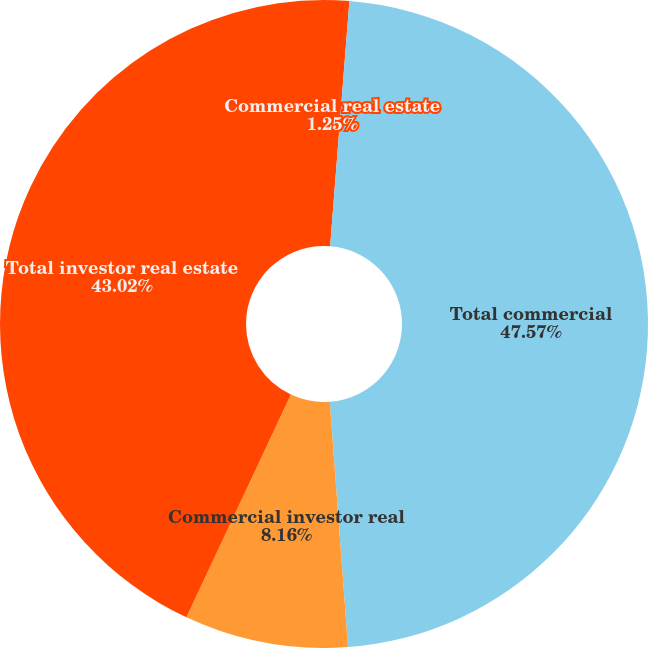Convert chart to OTSL. <chart><loc_0><loc_0><loc_500><loc_500><pie_chart><fcel>Commercial real estate<fcel>Total commercial<fcel>Commercial investor real<fcel>Total investor real estate<nl><fcel>1.25%<fcel>47.57%<fcel>8.16%<fcel>43.02%<nl></chart> 